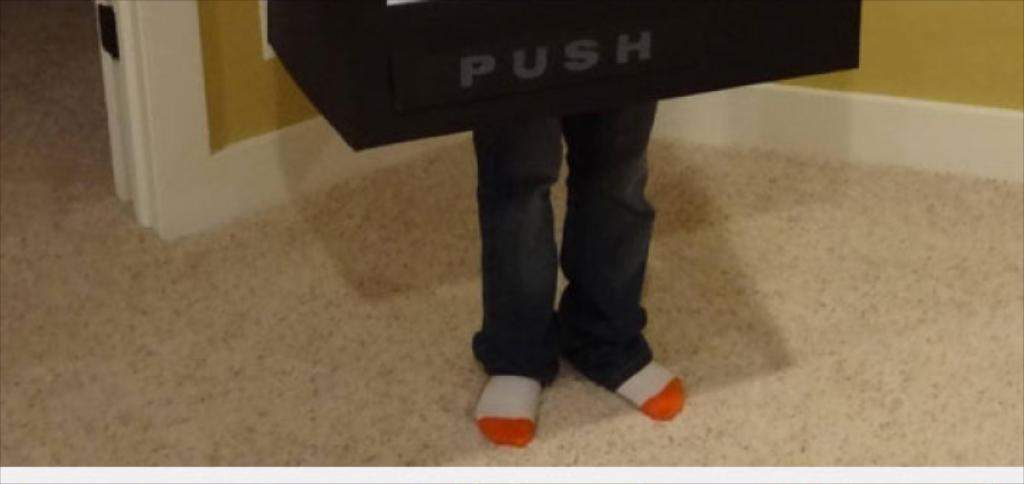What is located in the center of the image? There are two legs in the center of the image. What object can be seen at the top side of the image? There is a push board at the top side of the image. Where is the door located in the image? There is a door in the top left side of the image. What type of square stitch can be seen in the image? There is no square stitch present in the image; it features two legs, a push board, and a door. How does the image show the process of creating a new design? The image does not show the process of creating a new design; it only displays the mentioned objects. 